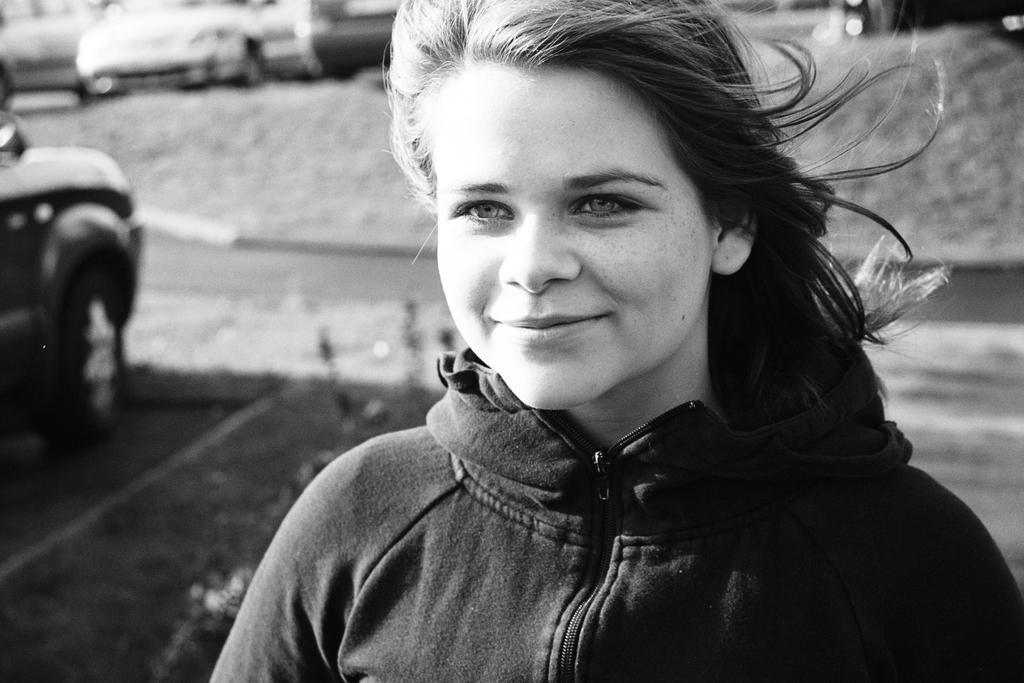Describe this image in one or two sentences. In this picture we can see a girl wearing black color jacket standing and giving a smile into the image. Behind we can see some cars are parked. 